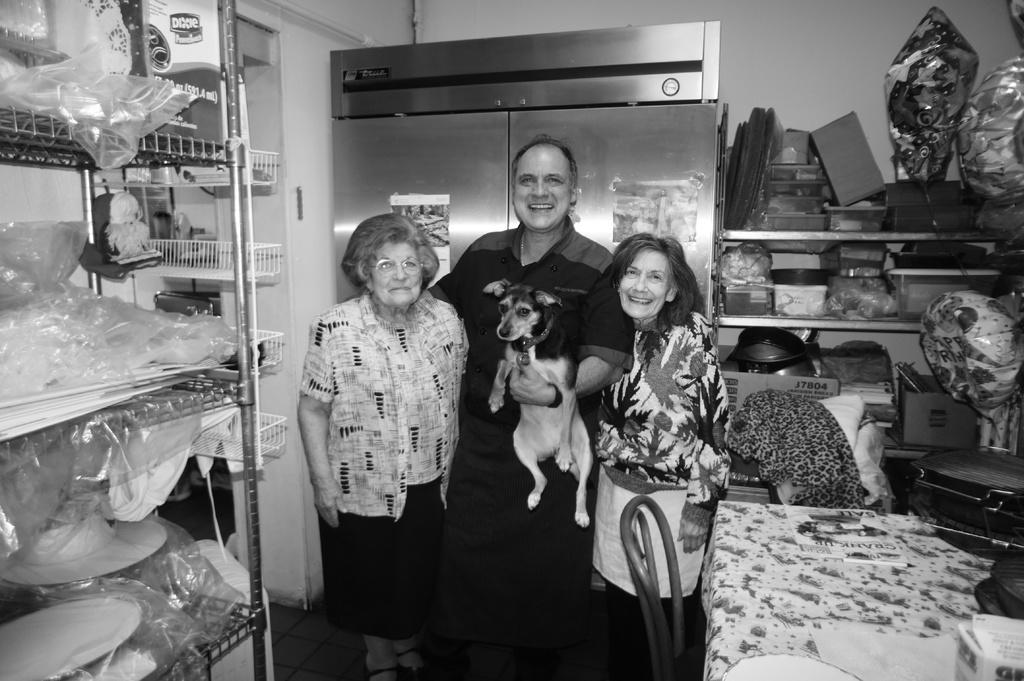What is the main subject of the image? There is a person in the image. What is the person wearing? The person is wearing a black shirt. What is the person doing with his left hand? The person is holding a dog in his left hand. How many women are in the image? There are two women in the image. Where are the women positioned in relation to the person? The women are on either side of the person. What is the top cause of the person's happiness in the image? The image does not provide information about the person's happiness or its cause, so we cannot answer this question. 